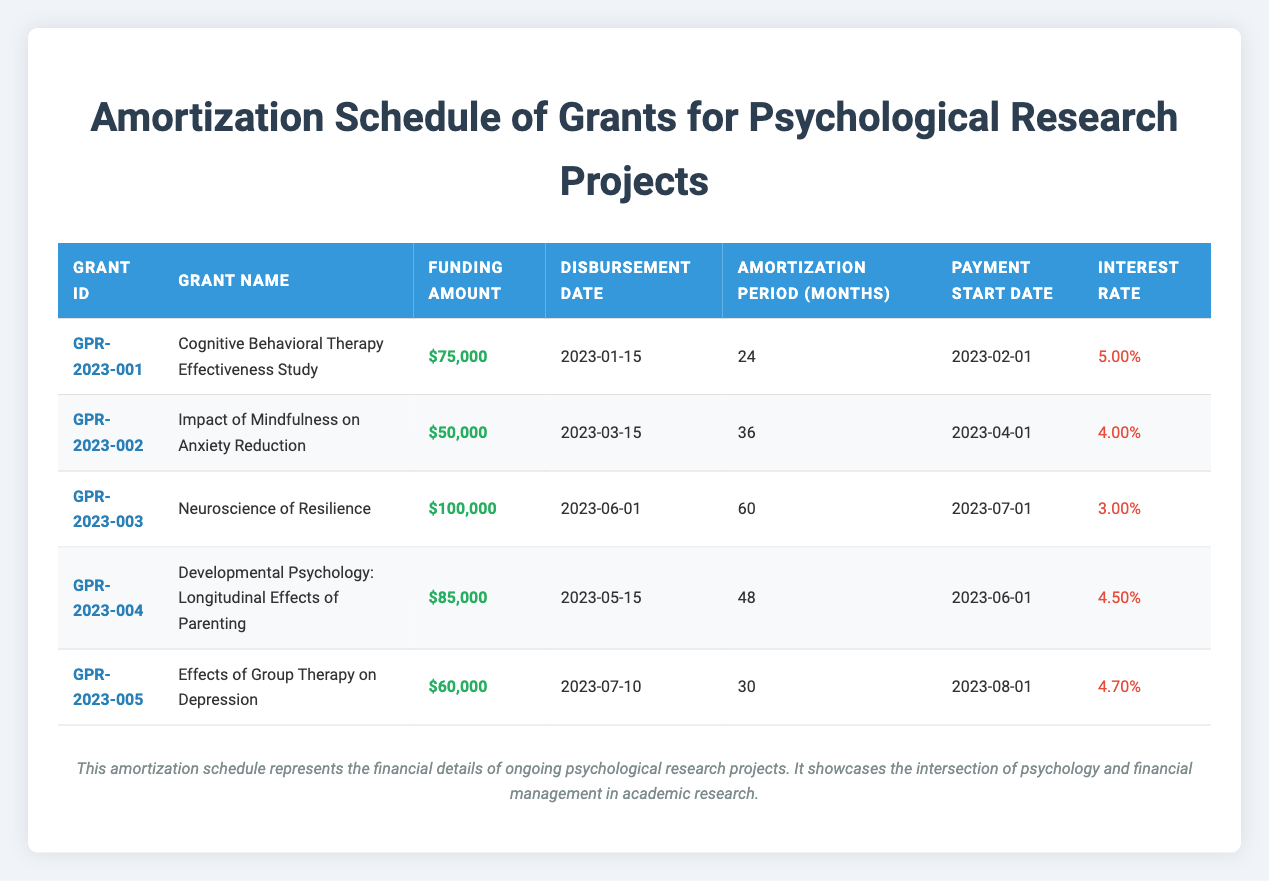What is the funding amount for the grant "Neuroscience of Resilience"? According to the table, the funding amount is listed next to the grant name "Neuroscience of Resilience." It shows $100,000.
Answer: $100,000 Which grant has the highest interest rate? The table lists the interest rates for each grant. By comparing them, "Cognitive Behavioral Therapy Effectiveness Study" has the highest rate at 5.00%.
Answer: Cognitive Behavioral Therapy Effectiveness Study What is the total funding amount for all the grants combined? To find the total funding amount, sum the individual amounts: $75,000 + $50,000 + $100,000 + $85,000 + $60,000 = $370,000.
Answer: $370,000 Is the amortization period for "Effects of Group Therapy on Depression" longer than for "Impact of Mindfulness on Anxiety Reduction"? The amortization periods are 30 months for "Effects of Group Therapy on Depression" and 36 months for "Impact of Mindfulness on Anxiety Reduction." Since 30 is less than 36, the statement is false.
Answer: No What is the average interest rate of all the grants? To calculate the average interest rate, first sum the rates: 5.00% + 4.00% + 3.00% + 4.50% + 4.70% = 21.20%. Then divide by the number of grants (5): 21.20% / 5 = 4.24%.
Answer: 4.24% 